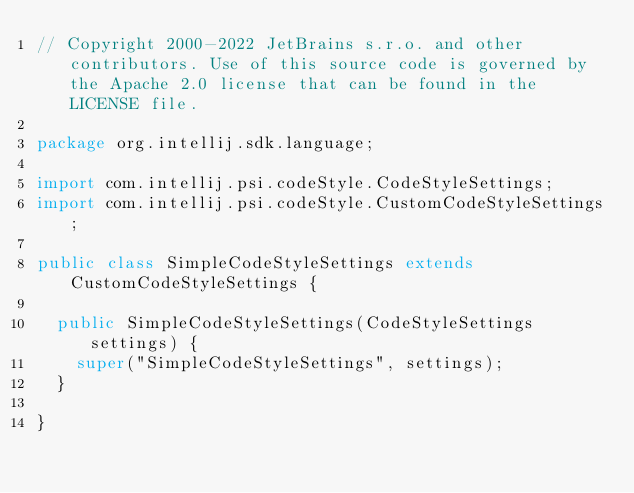Convert code to text. <code><loc_0><loc_0><loc_500><loc_500><_Java_>// Copyright 2000-2022 JetBrains s.r.o. and other contributors. Use of this source code is governed by the Apache 2.0 license that can be found in the LICENSE file.

package org.intellij.sdk.language;

import com.intellij.psi.codeStyle.CodeStyleSettings;
import com.intellij.psi.codeStyle.CustomCodeStyleSettings;

public class SimpleCodeStyleSettings extends CustomCodeStyleSettings {

  public SimpleCodeStyleSettings(CodeStyleSettings settings) {
    super("SimpleCodeStyleSettings", settings);
  }

}
</code> 